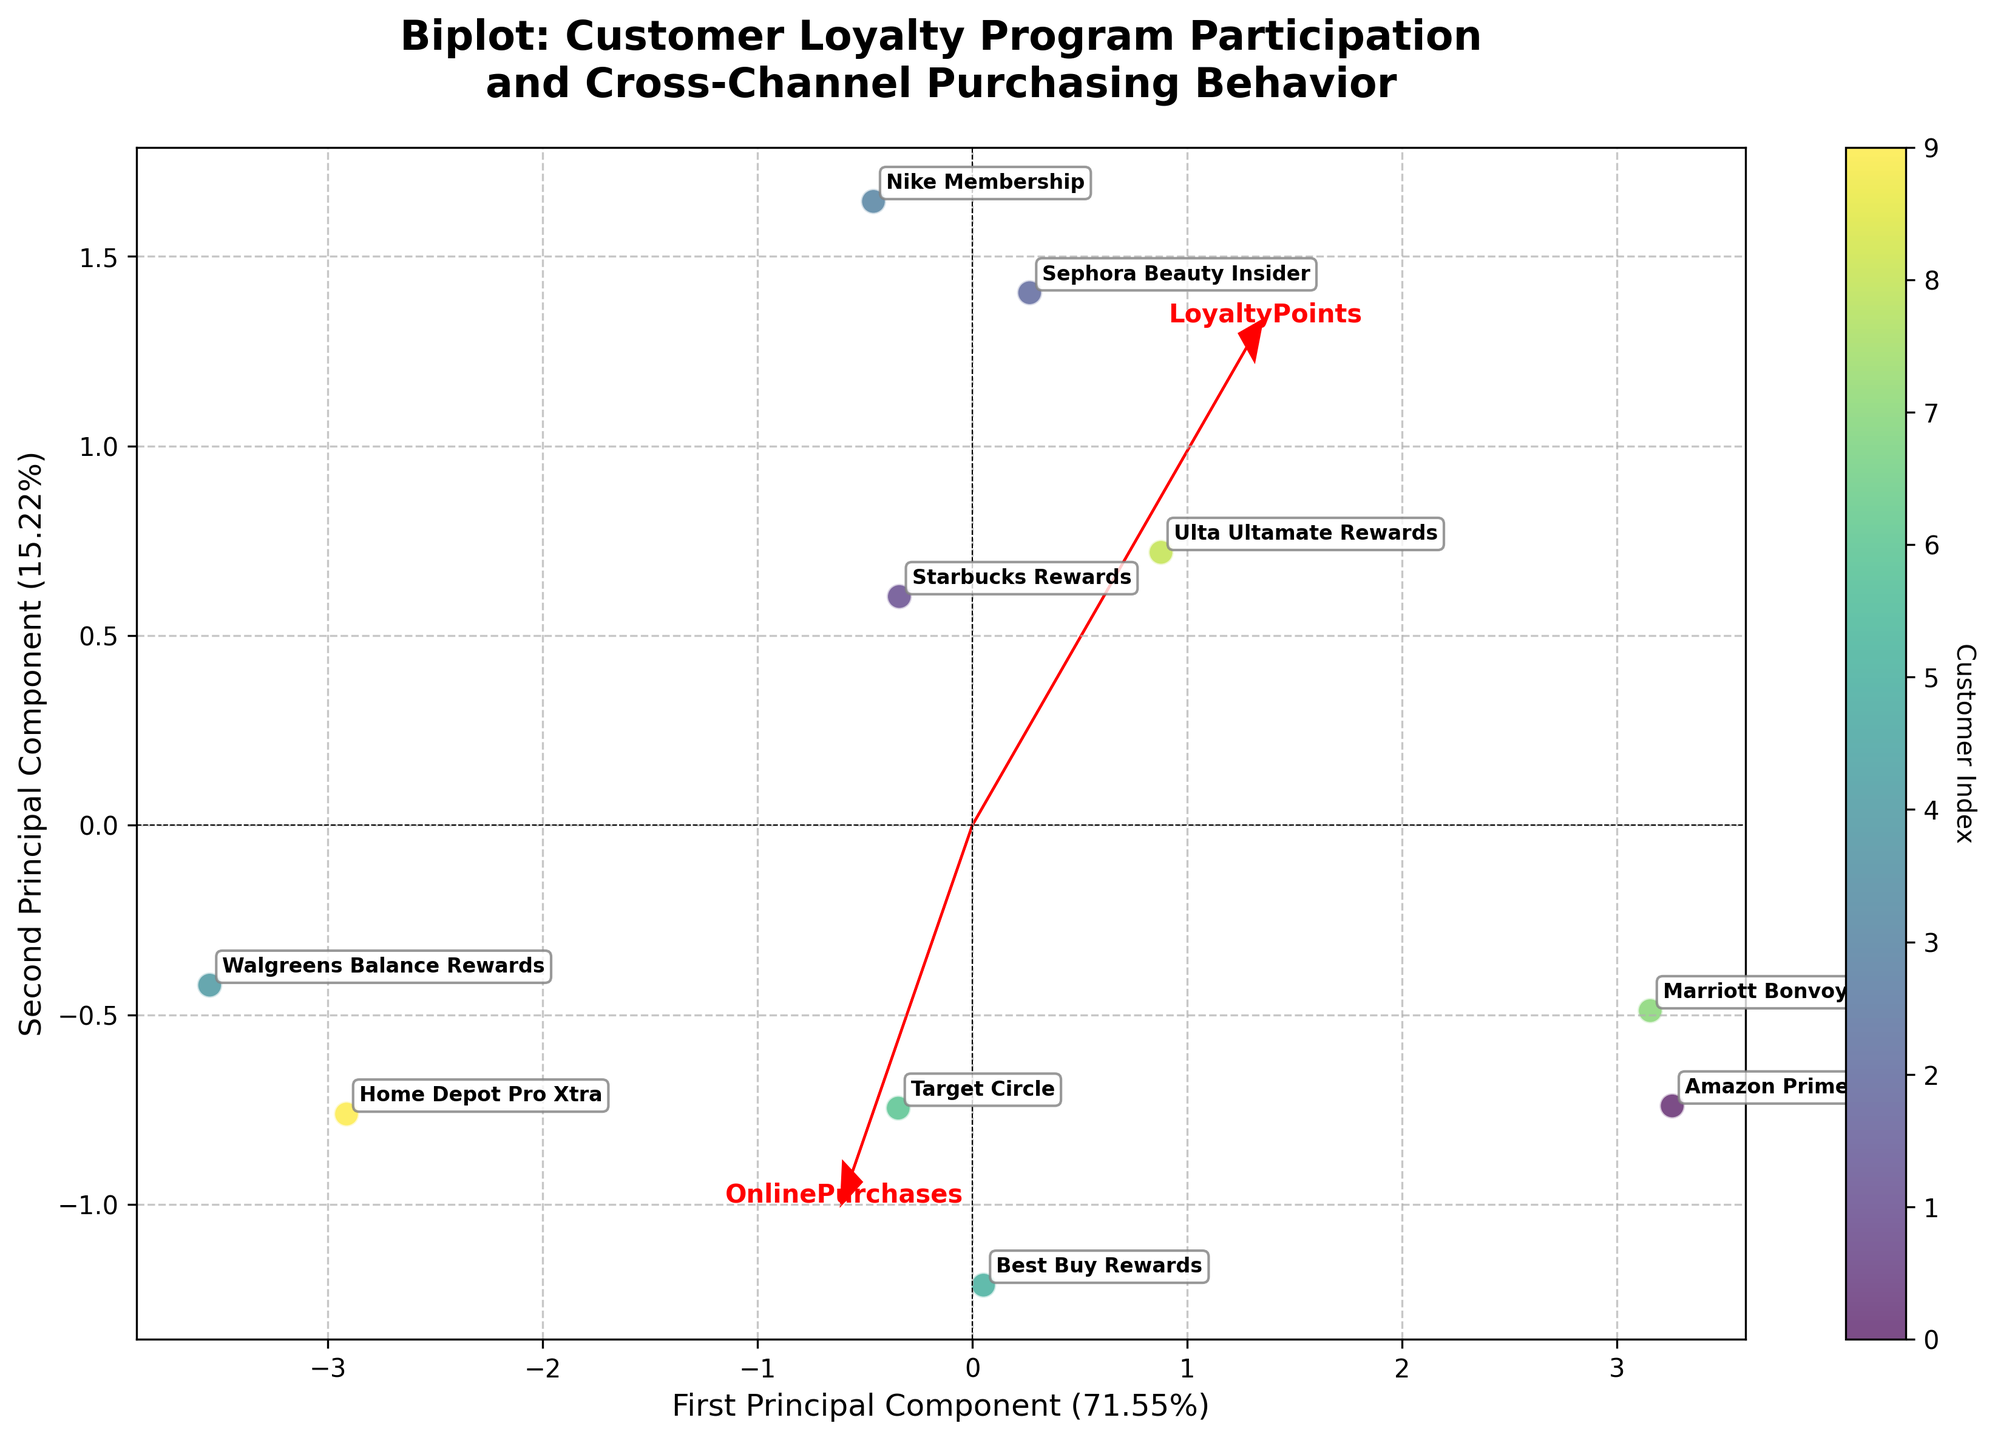What is the title of the plot? The title of the plot is typically positioned at the top center of the figure. From the given description, the title is "Biplot: Customer Loyalty Program Participation and Cross-Channel Purchasing Behavior."
Answer: Biplot: Customer Loyalty Program Participation and Cross-Channel Purchasing Behavior Which axis represents the First Principal Component, and what percentage of the variance does it explain? The x-axis represents the First Principal Component, as indicated by the label "First Principal Component." It explains 54.65% of the variance, as stated in the axis title.
Answer: The x-axis; 54.65% What are the two customers with the highest values on the First Principal Component? By looking at the plot, the two data points furthest to the right on the x-axis (First Principal Component) can be identified as "Amazon Prime" and "Marriott Bonvoy."
Answer: Amazon Prime and Marriott Bonvoy Which feature vector is closest to the First Principal Component’s axis? The feature vector that has the smallest angle with the First Principal Component's axis will be closest. This can be seen visually from the plot where the arrow represents the feature vector.
Answer: LoyaltyPoints How many customers have negative values on the Second Principal Component? Identify the data points that appear below the horizontal line at y=0, which represents the zero point on the Second Principal Component axis.
Answer: Three customers Which customer has the highest value on the Second Principal Component? Identify the data point that is located highest on the y-axis (Second Principal Component). According to the plot, this would be the customer furthest up vertically.
Answer: Nike Membership Which feature vectors have a positive correlation? Positive correlation between feature vectors can be identified by arrows pointing in the same general direction. Arrows pointing in opposite directions suggest negative correlation.
Answer: EmailEngagement and SocialMediaInteractions Do "OnlinePurchases" and "InStorePurchases" vectors show a strong correlation? From the plot, if the arrows for these features point in similar directions or share a similar angle with the origin, they have a strong correlation. If they point in notably different directions, the correlation is weaker.
Answer: No How does "EmailEngagement" compare to "InStorePurchases" in terms of their angle with the First Principal Component? The feature vectors' angles with the First Principal Component axis are determined visually. "EmailEngagement" should be more aligned with the x-axis than "InStorePurchases" if it has a lower angle.
Answer: EmailEngagement is more aligned (lower angle) Which customer data points are closer to the origin and what does it signify? Customer data points near the origin suggest they are less significant along both principal components, which likely indicates more average behavior in the analyzed dimensions. Check points closest to (0,0) to answer.
Answer: Walgreens Balance Rewards and Home Depot Pro Xtra 